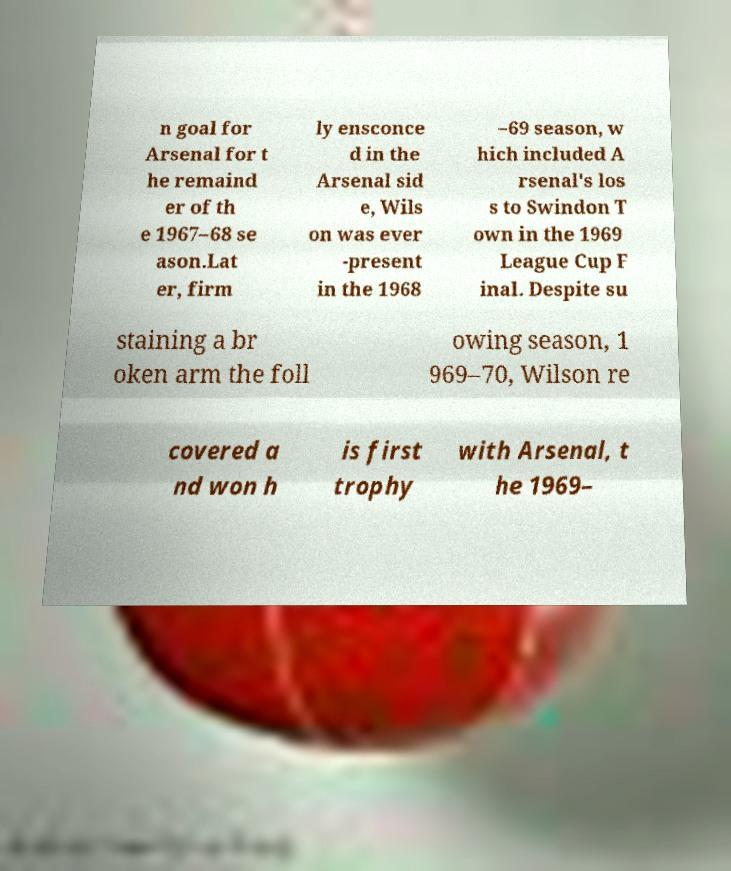I need the written content from this picture converted into text. Can you do that? n goal for Arsenal for t he remaind er of th e 1967–68 se ason.Lat er, firm ly ensconce d in the Arsenal sid e, Wils on was ever -present in the 1968 –69 season, w hich included A rsenal's los s to Swindon T own in the 1969 League Cup F inal. Despite su staining a br oken arm the foll owing season, 1 969–70, Wilson re covered a nd won h is first trophy with Arsenal, t he 1969– 